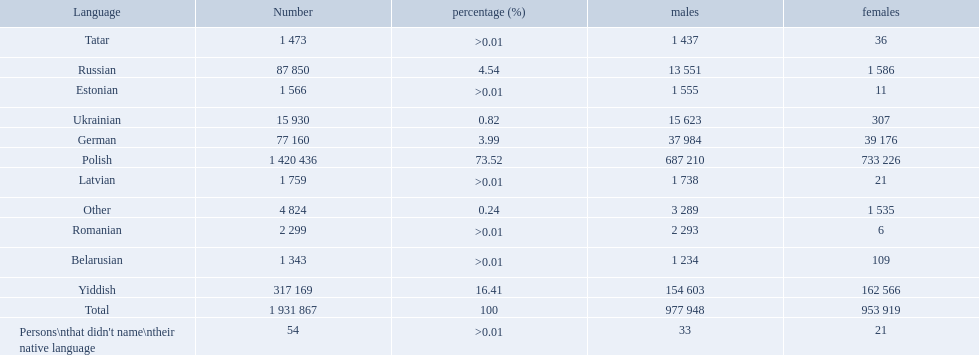How many languages are there? Polish, Yiddish, Russian, German, Ukrainian, Romanian, Latvian, Estonian, Tatar, Belarusian. Which language do more people speak? Polish. What languages are spoken in the warsaw governorate? Polish, Yiddish, Russian, German, Ukrainian, Romanian, Latvian, Estonian, Tatar, Belarusian. Which are the top five languages? Polish, Yiddish, Russian, German, Ukrainian. Of those which is the 2nd most frequently spoken? Yiddish. What named native languages spoken in the warsaw governorate have more males then females? Russian, Ukrainian, Romanian, Latvian, Estonian, Tatar, Belarusian. Which of those have less then 500 males listed? Romanian, Latvian, Estonian, Tatar, Belarusian. Of the remaining languages which of them have less then 20 females? Romanian, Estonian. Which of these has the highest total number listed? Romanian. 